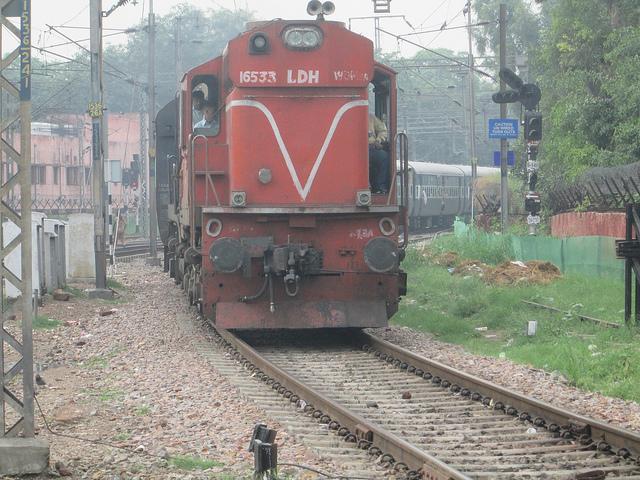How many trains are there?
Give a very brief answer. 1. 